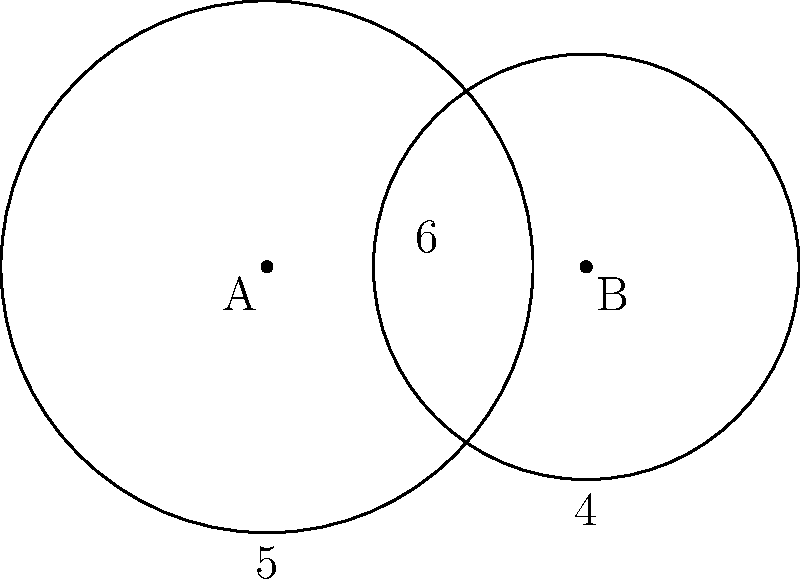Two circular easements on a property overlap as shown in the diagram. Easement A has a radius of 5 units, and easement B has a radius of 4 units. The centers of the easements are 6 units apart. Calculate the area of the overlapping region to the nearest square unit. How might this information be relevant in a property dispute case? To solve this problem, we'll use the formula for the area of overlap between two circles. The steps are as follows:

1) First, we need to calculate the distance $d$ between the centers of the circles. This is given as 6 units.

2) Next, we'll use the formula for the area of overlap:

   $$A = r_1^2 \arccos(\frac{d^2 + r_1^2 - r_2^2}{2dr_1}) + r_2^2 \arccos(\frac{d^2 + r_2^2 - r_1^2}{2dr_2}) - \frac{1}{2}\sqrt{(-d+r_1+r_2)(d+r_1-r_2)(d-r_1+r_2)(d+r_1+r_2)}$$

   Where $r_1 = 5$, $r_2 = 4$, and $d = 6$

3) Let's substitute these values:

   $$A = 5^2 \arccos(\frac{6^2 + 5^2 - 4^2}{2 \cdot 6 \cdot 5}) + 4^2 \arccos(\frac{6^2 + 4^2 - 5^2}{2 \cdot 6 \cdot 4}) - \frac{1}{2}\sqrt{(-6+5+4)(6+5-4)(6-5+4)(6+5+4)}$$

4) Simplify:

   $$A = 25 \arccos(\frac{61}{60}) + 16 \arccos(\frac{52}{48}) - \frac{1}{2}\sqrt{3 \cdot 7 \cdot 5 \cdot 15}$$

5) Calculate:

   $$A \approx 25 \cdot 0.2531 + 16 \cdot 0.7297 - \frac{1}{2} \cdot 17.8885$$

   $$A \approx 6.3275 + 11.6752 - 8.9442$$

   $$A \approx 9.0585$$

6) Rounding to the nearest square unit:

   $$A \approx 9 \text{ square units}$$

This information could be relevant in a property dispute case as it determines the exact area where the two easements overlap. This could be crucial in determining property rights, usage restrictions, or compensation in cases where the overlapping area is contested or needs to be utilized for a specific purpose.
Answer: 9 square units 